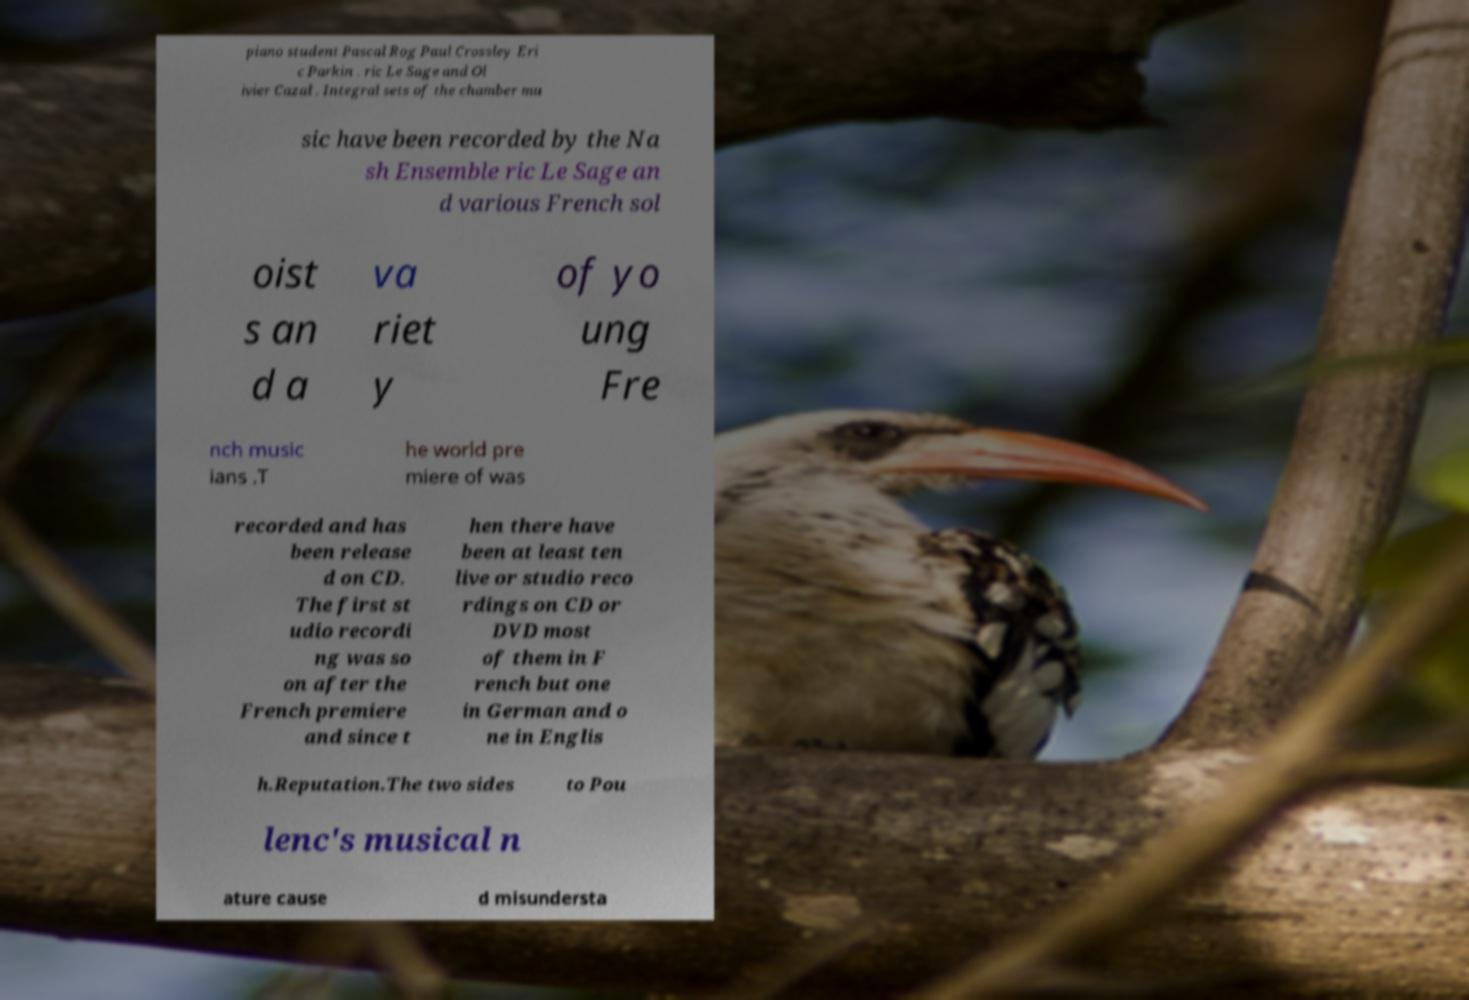There's text embedded in this image that I need extracted. Can you transcribe it verbatim? piano student Pascal Rog Paul Crossley Eri c Parkin . ric Le Sage and Ol ivier Cazal . Integral sets of the chamber mu sic have been recorded by the Na sh Ensemble ric Le Sage an d various French sol oist s an d a va riet y of yo ung Fre nch music ians .T he world pre miere of was recorded and has been release d on CD. The first st udio recordi ng was so on after the French premiere and since t hen there have been at least ten live or studio reco rdings on CD or DVD most of them in F rench but one in German and o ne in Englis h.Reputation.The two sides to Pou lenc's musical n ature cause d misundersta 